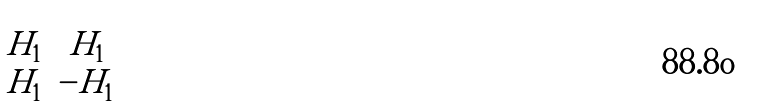<formula> <loc_0><loc_0><loc_500><loc_500>\begin{bmatrix} H _ { 1 } & H _ { 1 } \\ H _ { 1 } & - H _ { 1 } \end{bmatrix}</formula> 